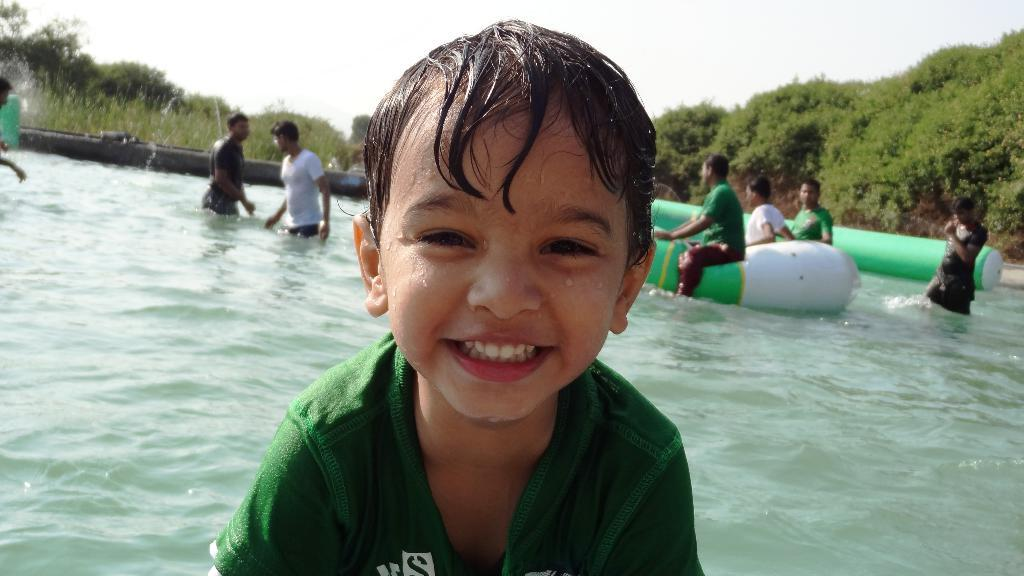Who is in the picture? There is a boy in the picture. What is the boy doing? The boy is smiling. What can be seen in the image besides the boy? There is water visible in the image, as well as inflatable objects in the water. What is visible in the background of the image? There are people, trees, and the sky visible in the background. What type of jam is the boy eating in the image? There is no jam present in the image; the boy is smiling and there is water with inflatable objects in the image. 